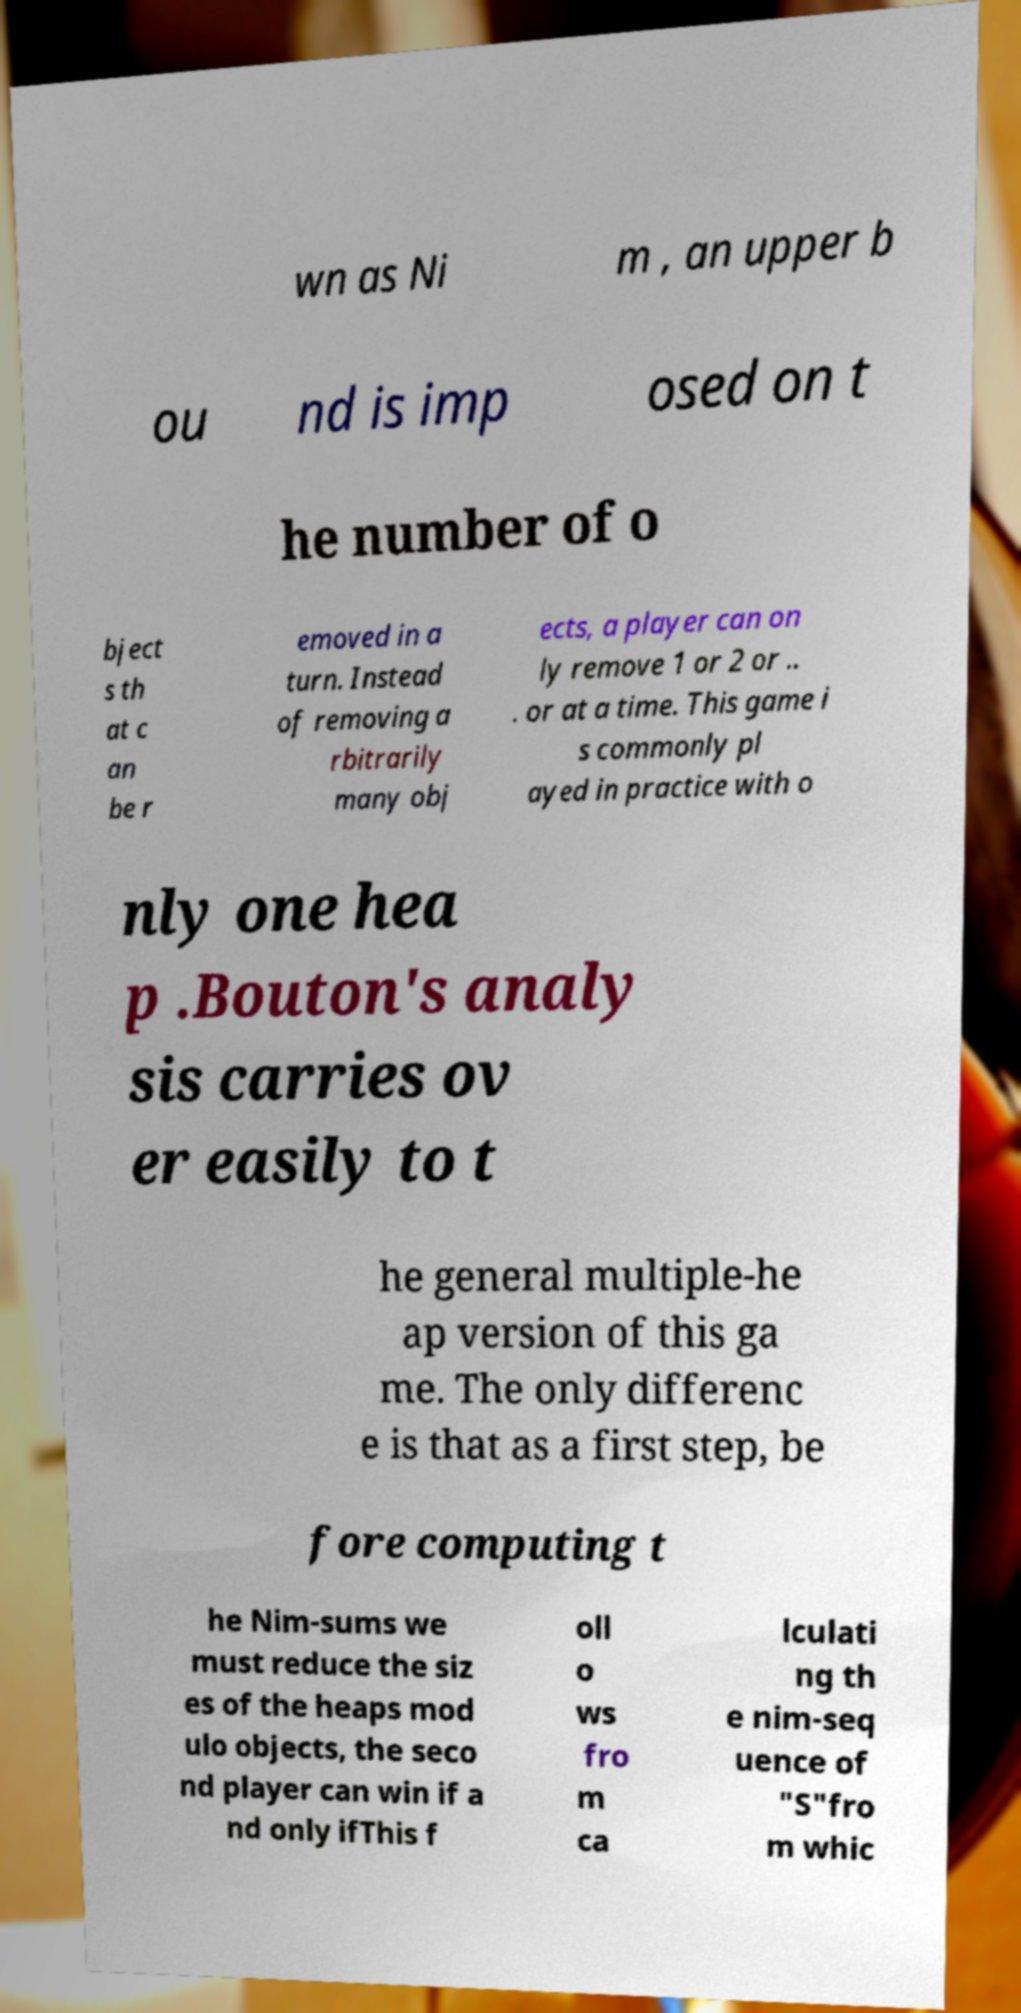Please read and relay the text visible in this image. What does it say? wn as Ni m , an upper b ou nd is imp osed on t he number of o bject s th at c an be r emoved in a turn. Instead of removing a rbitrarily many obj ects, a player can on ly remove 1 or 2 or .. . or at a time. This game i s commonly pl ayed in practice with o nly one hea p .Bouton's analy sis carries ov er easily to t he general multiple-he ap version of this ga me. The only differenc e is that as a first step, be fore computing t he Nim-sums we must reduce the siz es of the heaps mod ulo objects, the seco nd player can win if a nd only ifThis f oll o ws fro m ca lculati ng th e nim-seq uence of "S"fro m whic 